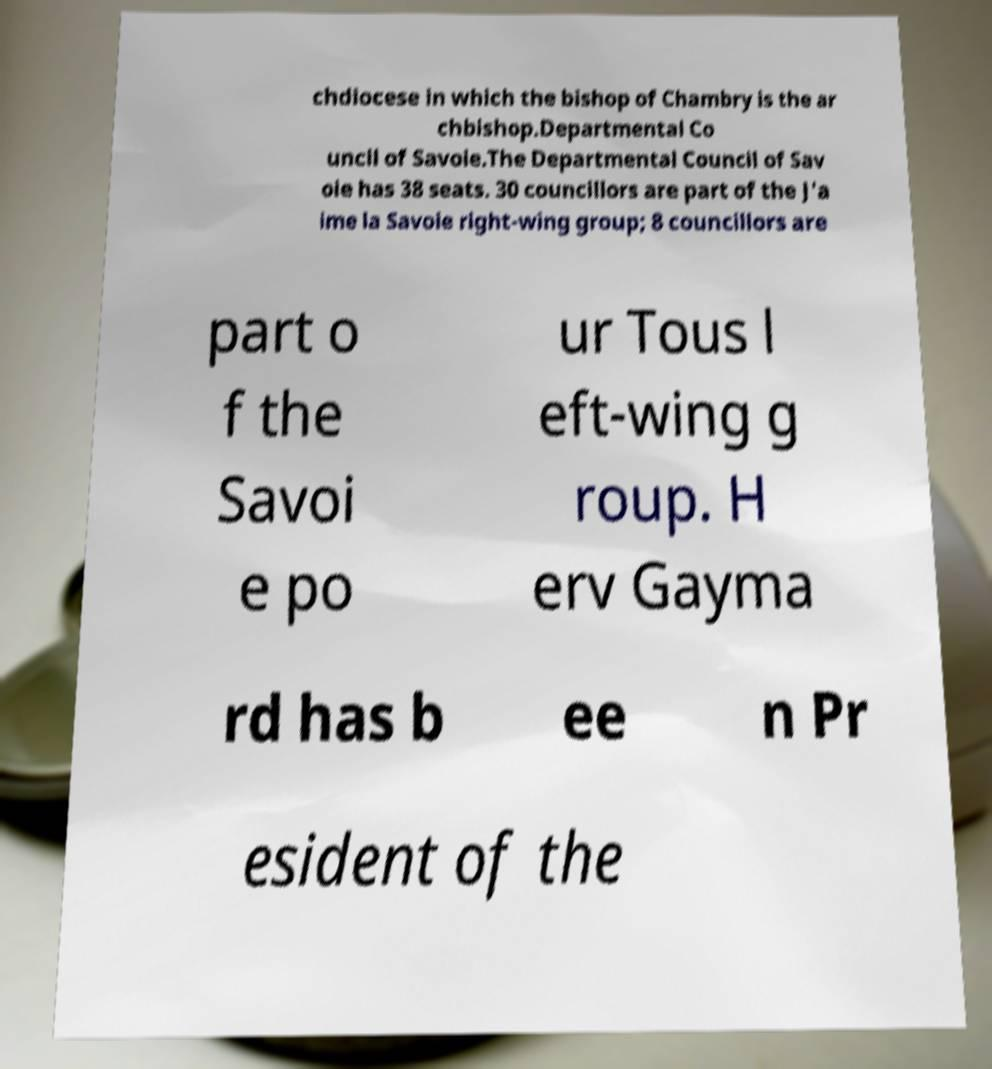Can you read and provide the text displayed in the image?This photo seems to have some interesting text. Can you extract and type it out for me? chdiocese in which the bishop of Chambry is the ar chbishop.Departmental Co uncil of Savoie.The Departmental Council of Sav oie has 38 seats. 30 councillors are part of the J'a ime la Savoie right-wing group; 8 councillors are part o f the Savoi e po ur Tous l eft-wing g roup. H erv Gayma rd has b ee n Pr esident of the 